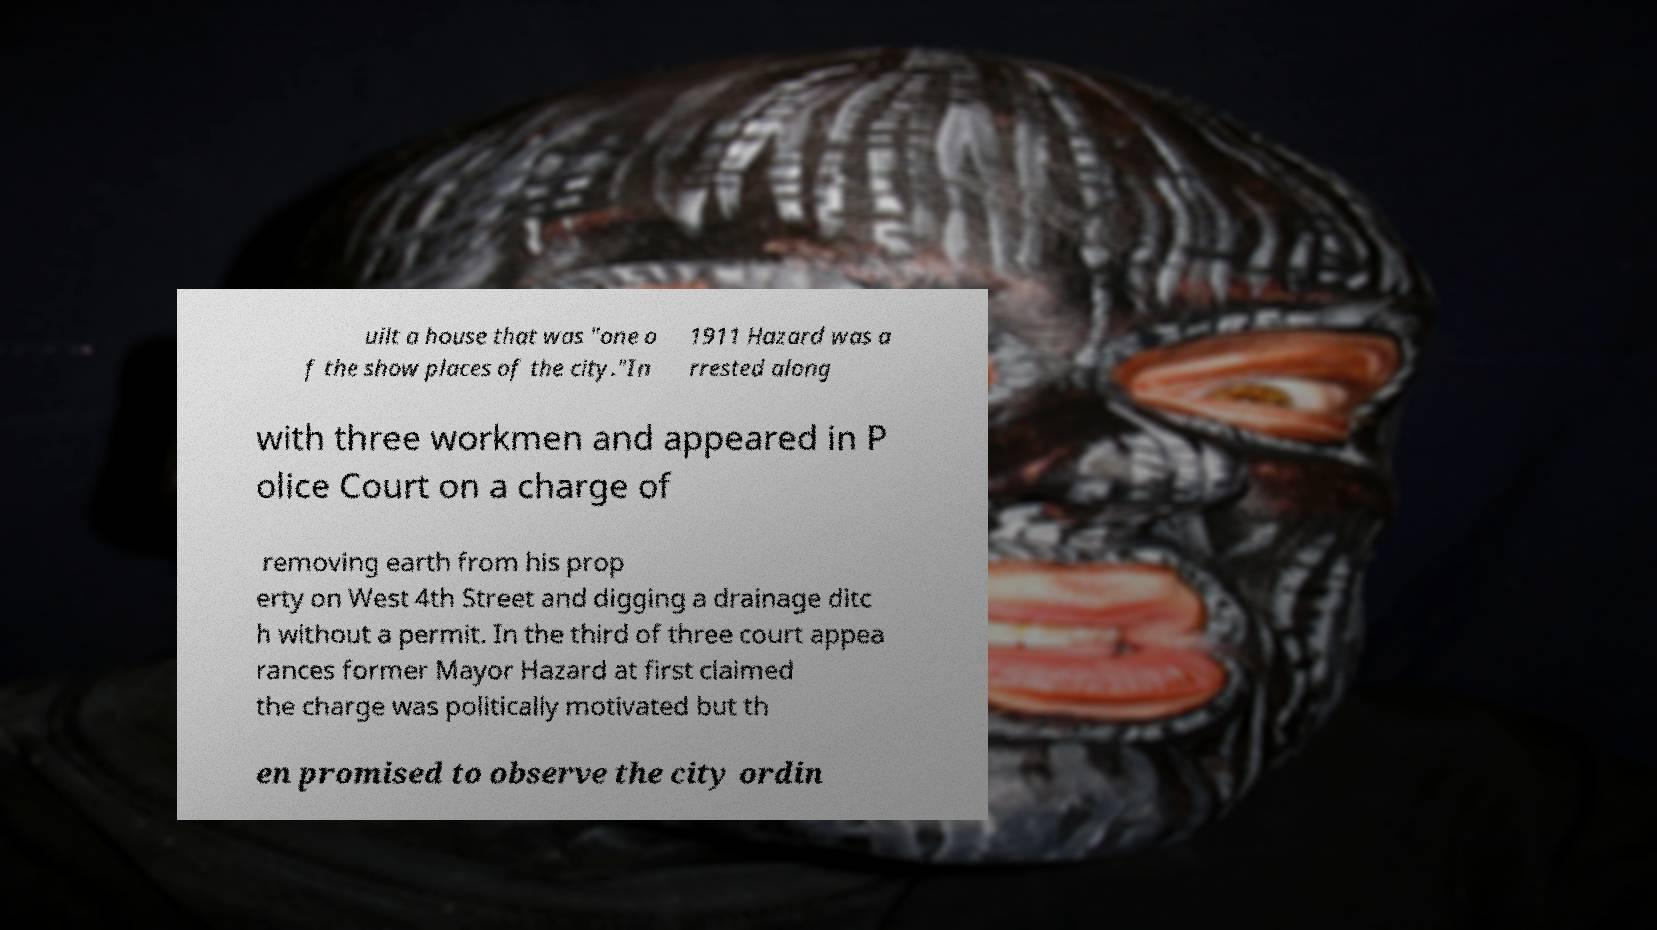Could you extract and type out the text from this image? uilt a house that was "one o f the show places of the city."In 1911 Hazard was a rrested along with three workmen and appeared in P olice Court on a charge of removing earth from his prop erty on West 4th Street and digging a drainage ditc h without a permit. In the third of three court appea rances former Mayor Hazard at first claimed the charge was politically motivated but th en promised to observe the city ordin 